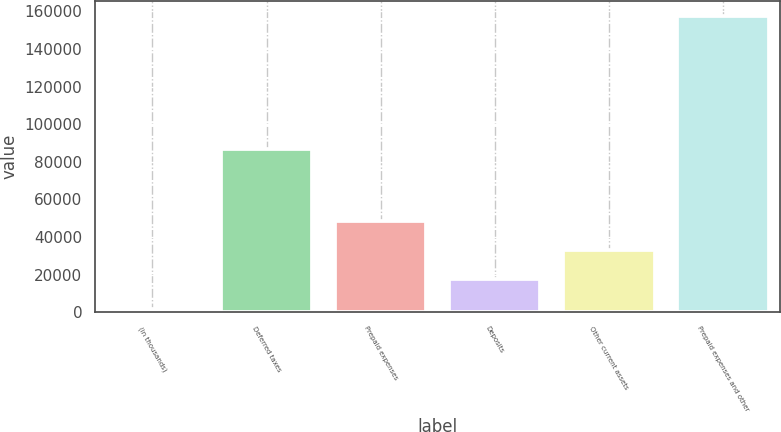<chart> <loc_0><loc_0><loc_500><loc_500><bar_chart><fcel>(in thousands)<fcel>Deferred taxes<fcel>Prepaid expenses<fcel>Deposits<fcel>Other current assets<fcel>Prepaid expenses and other<nl><fcel>2013<fcel>86929<fcel>48655.2<fcel>17560.4<fcel>33107.8<fcel>157487<nl></chart> 